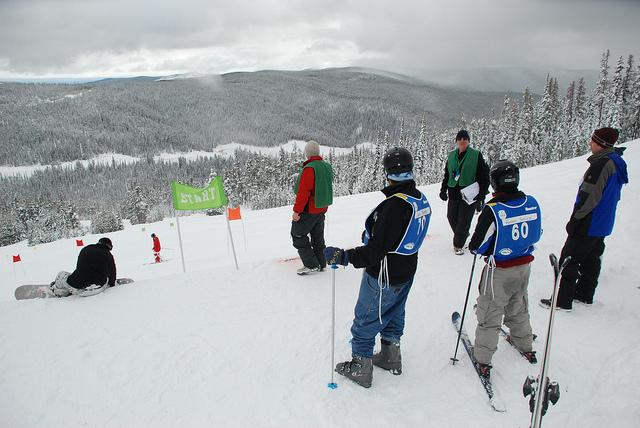Are they skiing as friends?
Write a very short answer. Yes. Are all the snowboarders standing?
Keep it brief. No. What color is the flag?
Keep it brief. Green. 